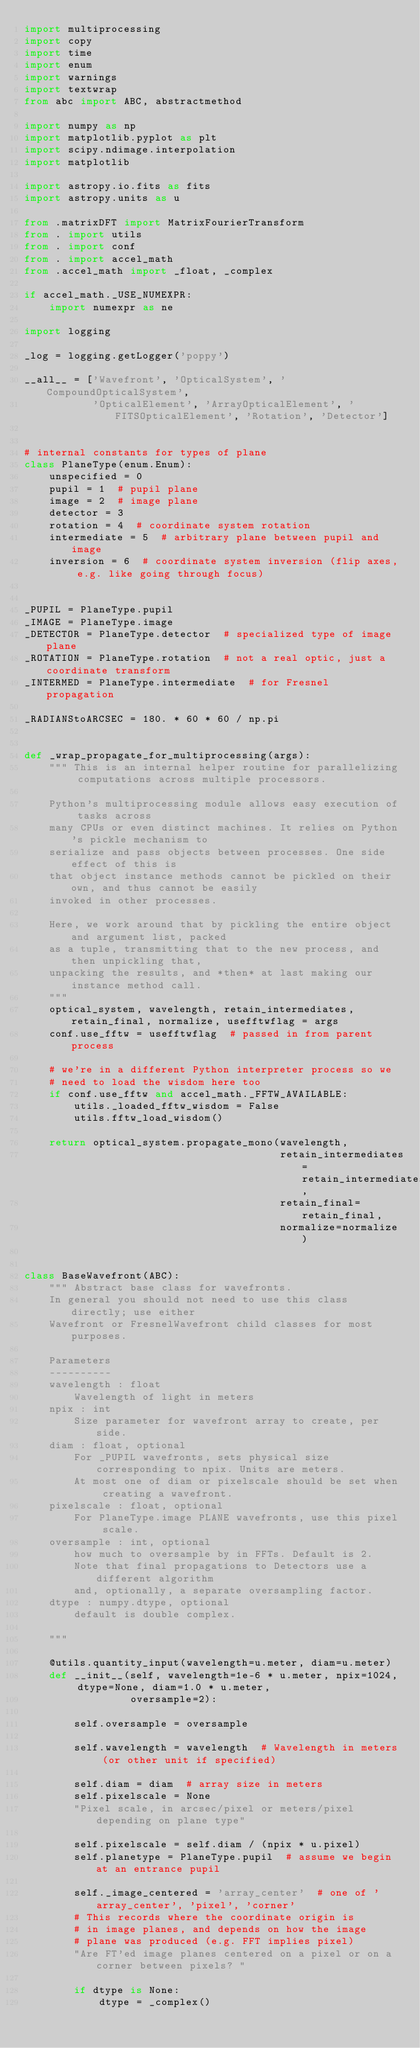<code> <loc_0><loc_0><loc_500><loc_500><_Python_>import multiprocessing
import copy
import time
import enum
import warnings
import textwrap
from abc import ABC, abstractmethod

import numpy as np
import matplotlib.pyplot as plt
import scipy.ndimage.interpolation
import matplotlib

import astropy.io.fits as fits
import astropy.units as u

from .matrixDFT import MatrixFourierTransform
from . import utils
from . import conf
from . import accel_math
from .accel_math import _float, _complex

if accel_math._USE_NUMEXPR:
    import numexpr as ne

import logging

_log = logging.getLogger('poppy')

__all__ = ['Wavefront', 'OpticalSystem', 'CompoundOpticalSystem',
           'OpticalElement', 'ArrayOpticalElement', 'FITSOpticalElement', 'Rotation', 'Detector']


# internal constants for types of plane
class PlaneType(enum.Enum):
    unspecified = 0
    pupil = 1  # pupil plane
    image = 2  # image plane
    detector = 3
    rotation = 4  # coordinate system rotation
    intermediate = 5  # arbitrary plane between pupil and image
    inversion = 6  # coordinate system inversion (flip axes, e.g. like going through focus)


_PUPIL = PlaneType.pupil
_IMAGE = PlaneType.image
_DETECTOR = PlaneType.detector  # specialized type of image plane
_ROTATION = PlaneType.rotation  # not a real optic, just a coordinate transform
_INTERMED = PlaneType.intermediate  # for Fresnel propagation

_RADIANStoARCSEC = 180. * 60 * 60 / np.pi


def _wrap_propagate_for_multiprocessing(args):
    """ This is an internal helper routine for parallelizing computations across multiple processors.

    Python's multiprocessing module allows easy execution of tasks across
    many CPUs or even distinct machines. It relies on Python's pickle mechanism to
    serialize and pass objects between processes. One side effect of this is
    that object instance methods cannot be pickled on their own, and thus cannot be easily
    invoked in other processes.

    Here, we work around that by pickling the entire object and argument list, packed
    as a tuple, transmitting that to the new process, and then unpickling that,
    unpacking the results, and *then* at last making our instance method call.
    """
    optical_system, wavelength, retain_intermediates, retain_final, normalize, usefftwflag = args
    conf.use_fftw = usefftwflag  # passed in from parent process

    # we're in a different Python interpreter process so we
    # need to load the wisdom here too
    if conf.use_fftw and accel_math._FFTW_AVAILABLE:
        utils._loaded_fftw_wisdom = False
        utils.fftw_load_wisdom()

    return optical_system.propagate_mono(wavelength,
                                         retain_intermediates=retain_intermediates,
                                         retain_final=retain_final,
                                         normalize=normalize)


class BaseWavefront(ABC):
    """ Abstract base class for wavefronts.
    In general you should not need to use this class directly; use either
    Wavefront or FresnelWavefront child classes for most purposes.

    Parameters
    ----------
    wavelength : float
        Wavelength of light in meters
    npix : int
        Size parameter for wavefront array to create, per side.
    diam : float, optional
        For _PUPIL wavefronts, sets physical size corresponding to npix. Units are meters.
        At most one of diam or pixelscale should be set when creating a wavefront.
    pixelscale : float, optional
        For PlaneType.image PLANE wavefronts, use this pixel scale.
    oversample : int, optional
        how much to oversample by in FFTs. Default is 2.
        Note that final propagations to Detectors use a different algorithm
        and, optionally, a separate oversampling factor.
    dtype : numpy.dtype, optional
        default is double complex.

    """

    @utils.quantity_input(wavelength=u.meter, diam=u.meter)
    def __init__(self, wavelength=1e-6 * u.meter, npix=1024, dtype=None, diam=1.0 * u.meter,
                 oversample=2):

        self.oversample = oversample

        self.wavelength = wavelength  # Wavelength in meters (or other unit if specified)

        self.diam = diam  # array size in meters
        self.pixelscale = None
        "Pixel scale, in arcsec/pixel or meters/pixel depending on plane type"

        self.pixelscale = self.diam / (npix * u.pixel)
        self.planetype = PlaneType.pupil  # assume we begin at an entrance pupil

        self._image_centered = 'array_center'  # one of 'array_center', 'pixel', 'corner'
        # This records where the coordinate origin is
        # in image planes, and depends on how the image
        # plane was produced (e.g. FFT implies pixel)
        "Are FT'ed image planes centered on a pixel or on a corner between pixels? "

        if dtype is None:
            dtype = _complex()</code> 